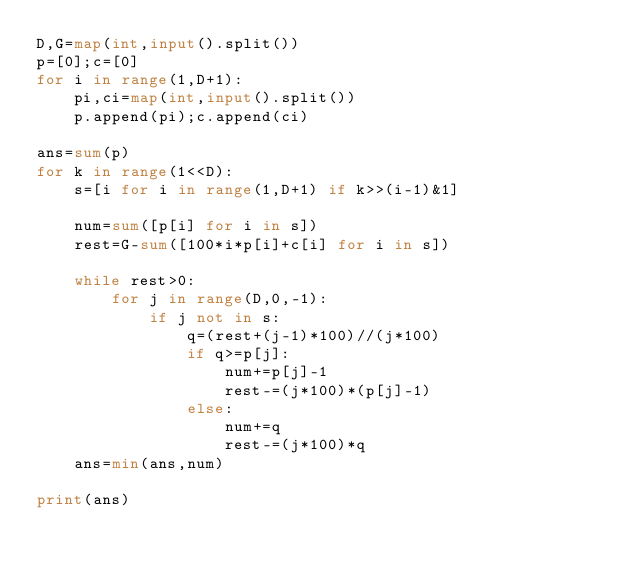<code> <loc_0><loc_0><loc_500><loc_500><_Python_>D,G=map(int,input().split())
p=[0];c=[0]
for i in range(1,D+1):
    pi,ci=map(int,input().split())
    p.append(pi);c.append(ci)

ans=sum(p)
for k in range(1<<D):
    s=[i for i in range(1,D+1) if k>>(i-1)&1]

    num=sum([p[i] for i in s])
    rest=G-sum([100*i*p[i]+c[i] for i in s])

    while rest>0:
        for j in range(D,0,-1):
            if j not in s:
                q=(rest+(j-1)*100)//(j*100) 
                if q>=p[j]:
                    num+=p[j]-1
                    rest-=(j*100)*(p[j]-1)
                else:
                    num+=q
                    rest-=(j*100)*q
    ans=min(ans,num)

print(ans)</code> 